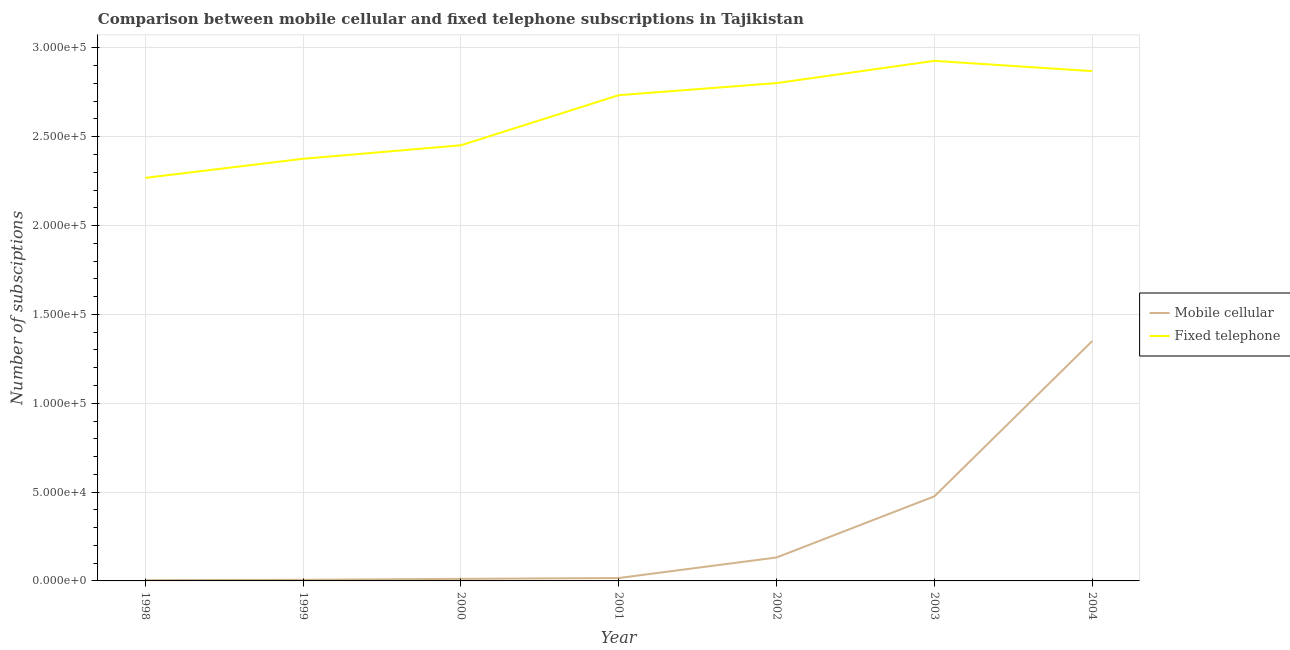Does the line corresponding to number of mobile cellular subscriptions intersect with the line corresponding to number of fixed telephone subscriptions?
Your response must be concise. No. Is the number of lines equal to the number of legend labels?
Make the answer very short. Yes. What is the number of mobile cellular subscriptions in 1998?
Your answer should be very brief. 420. Across all years, what is the maximum number of mobile cellular subscriptions?
Your response must be concise. 1.35e+05. Across all years, what is the minimum number of mobile cellular subscriptions?
Offer a very short reply. 420. In which year was the number of fixed telephone subscriptions maximum?
Your response must be concise. 2003. In which year was the number of fixed telephone subscriptions minimum?
Make the answer very short. 1998. What is the total number of fixed telephone subscriptions in the graph?
Provide a succinct answer. 1.84e+06. What is the difference between the number of fixed telephone subscriptions in 1999 and that in 2000?
Your response must be concise. -7592. What is the difference between the number of fixed telephone subscriptions in 1998 and the number of mobile cellular subscriptions in 2001?
Your answer should be compact. 2.25e+05. What is the average number of mobile cellular subscriptions per year?
Offer a very short reply. 2.85e+04. In the year 2004, what is the difference between the number of mobile cellular subscriptions and number of fixed telephone subscriptions?
Provide a short and direct response. -1.52e+05. What is the ratio of the number of mobile cellular subscriptions in 1999 to that in 2002?
Give a very brief answer. 0.05. Is the difference between the number of mobile cellular subscriptions in 2000 and 2001 greater than the difference between the number of fixed telephone subscriptions in 2000 and 2001?
Ensure brevity in your answer.  Yes. What is the difference between the highest and the second highest number of fixed telephone subscriptions?
Provide a short and direct response. 5790. What is the difference between the highest and the lowest number of fixed telephone subscriptions?
Your answer should be compact. 6.59e+04. Is the sum of the number of fixed telephone subscriptions in 1998 and 2004 greater than the maximum number of mobile cellular subscriptions across all years?
Make the answer very short. Yes. Is the number of mobile cellular subscriptions strictly greater than the number of fixed telephone subscriptions over the years?
Your answer should be compact. No. Is the number of mobile cellular subscriptions strictly less than the number of fixed telephone subscriptions over the years?
Offer a terse response. Yes. How many lines are there?
Provide a short and direct response. 2. How many years are there in the graph?
Make the answer very short. 7. What is the difference between two consecutive major ticks on the Y-axis?
Your response must be concise. 5.00e+04. Are the values on the major ticks of Y-axis written in scientific E-notation?
Your response must be concise. Yes. Does the graph contain grids?
Offer a terse response. Yes. Where does the legend appear in the graph?
Give a very brief answer. Center right. What is the title of the graph?
Make the answer very short. Comparison between mobile cellular and fixed telephone subscriptions in Tajikistan. Does "Age 65(male)" appear as one of the legend labels in the graph?
Provide a short and direct response. No. What is the label or title of the Y-axis?
Make the answer very short. Number of subsciptions. What is the Number of subsciptions in Mobile cellular in 1998?
Provide a succinct answer. 420. What is the Number of subsciptions in Fixed telephone in 1998?
Your answer should be very brief. 2.27e+05. What is the Number of subsciptions in Mobile cellular in 1999?
Your answer should be compact. 625. What is the Number of subsciptions in Fixed telephone in 1999?
Your answer should be very brief. 2.38e+05. What is the Number of subsciptions in Mobile cellular in 2000?
Make the answer very short. 1160. What is the Number of subsciptions of Fixed telephone in 2000?
Offer a very short reply. 2.45e+05. What is the Number of subsciptions in Mobile cellular in 2001?
Your answer should be compact. 1630. What is the Number of subsciptions of Fixed telephone in 2001?
Offer a very short reply. 2.73e+05. What is the Number of subsciptions in Mobile cellular in 2002?
Offer a very short reply. 1.32e+04. What is the Number of subsciptions of Fixed telephone in 2002?
Make the answer very short. 2.80e+05. What is the Number of subsciptions in Mobile cellular in 2003?
Your response must be concise. 4.76e+04. What is the Number of subsciptions in Fixed telephone in 2003?
Offer a very short reply. 2.93e+05. What is the Number of subsciptions in Mobile cellular in 2004?
Your answer should be very brief. 1.35e+05. What is the Number of subsciptions of Fixed telephone in 2004?
Offer a terse response. 2.87e+05. Across all years, what is the maximum Number of subsciptions of Mobile cellular?
Provide a succinct answer. 1.35e+05. Across all years, what is the maximum Number of subsciptions in Fixed telephone?
Your answer should be very brief. 2.93e+05. Across all years, what is the minimum Number of subsciptions in Mobile cellular?
Keep it short and to the point. 420. Across all years, what is the minimum Number of subsciptions of Fixed telephone?
Provide a succinct answer. 2.27e+05. What is the total Number of subsciptions in Mobile cellular in the graph?
Give a very brief answer. 2.00e+05. What is the total Number of subsciptions of Fixed telephone in the graph?
Keep it short and to the point. 1.84e+06. What is the difference between the Number of subsciptions in Mobile cellular in 1998 and that in 1999?
Offer a terse response. -205. What is the difference between the Number of subsciptions in Fixed telephone in 1998 and that in 1999?
Provide a short and direct response. -1.07e+04. What is the difference between the Number of subsciptions of Mobile cellular in 1998 and that in 2000?
Make the answer very short. -740. What is the difference between the Number of subsciptions in Fixed telephone in 1998 and that in 2000?
Offer a terse response. -1.83e+04. What is the difference between the Number of subsciptions in Mobile cellular in 1998 and that in 2001?
Offer a terse response. -1210. What is the difference between the Number of subsciptions of Fixed telephone in 1998 and that in 2001?
Your response must be concise. -4.65e+04. What is the difference between the Number of subsciptions of Mobile cellular in 1998 and that in 2002?
Provide a succinct answer. -1.28e+04. What is the difference between the Number of subsciptions in Fixed telephone in 1998 and that in 2002?
Give a very brief answer. -5.33e+04. What is the difference between the Number of subsciptions in Mobile cellular in 1998 and that in 2003?
Offer a very short reply. -4.72e+04. What is the difference between the Number of subsciptions of Fixed telephone in 1998 and that in 2003?
Your response must be concise. -6.59e+04. What is the difference between the Number of subsciptions in Mobile cellular in 1998 and that in 2004?
Your answer should be compact. -1.35e+05. What is the difference between the Number of subsciptions in Fixed telephone in 1998 and that in 2004?
Provide a succinct answer. -6.01e+04. What is the difference between the Number of subsciptions in Mobile cellular in 1999 and that in 2000?
Make the answer very short. -535. What is the difference between the Number of subsciptions in Fixed telephone in 1999 and that in 2000?
Your answer should be compact. -7592. What is the difference between the Number of subsciptions in Mobile cellular in 1999 and that in 2001?
Keep it short and to the point. -1005. What is the difference between the Number of subsciptions of Fixed telephone in 1999 and that in 2001?
Your response must be concise. -3.58e+04. What is the difference between the Number of subsciptions of Mobile cellular in 1999 and that in 2002?
Provide a short and direct response. -1.26e+04. What is the difference between the Number of subsciptions of Fixed telephone in 1999 and that in 2002?
Give a very brief answer. -4.26e+04. What is the difference between the Number of subsciptions in Mobile cellular in 1999 and that in 2003?
Offer a terse response. -4.70e+04. What is the difference between the Number of subsciptions of Fixed telephone in 1999 and that in 2003?
Provide a short and direct response. -5.51e+04. What is the difference between the Number of subsciptions in Mobile cellular in 1999 and that in 2004?
Your response must be concise. -1.34e+05. What is the difference between the Number of subsciptions in Fixed telephone in 1999 and that in 2004?
Provide a succinct answer. -4.93e+04. What is the difference between the Number of subsciptions in Mobile cellular in 2000 and that in 2001?
Provide a short and direct response. -470. What is the difference between the Number of subsciptions of Fixed telephone in 2000 and that in 2001?
Your answer should be very brief. -2.82e+04. What is the difference between the Number of subsciptions of Mobile cellular in 2000 and that in 2002?
Make the answer very short. -1.20e+04. What is the difference between the Number of subsciptions in Fixed telephone in 2000 and that in 2002?
Your answer should be very brief. -3.50e+04. What is the difference between the Number of subsciptions of Mobile cellular in 2000 and that in 2003?
Offer a terse response. -4.65e+04. What is the difference between the Number of subsciptions of Fixed telephone in 2000 and that in 2003?
Your answer should be very brief. -4.75e+04. What is the difference between the Number of subsciptions in Mobile cellular in 2000 and that in 2004?
Provide a succinct answer. -1.34e+05. What is the difference between the Number of subsciptions of Fixed telephone in 2000 and that in 2004?
Your answer should be very brief. -4.17e+04. What is the difference between the Number of subsciptions in Mobile cellular in 2001 and that in 2002?
Make the answer very short. -1.16e+04. What is the difference between the Number of subsciptions in Fixed telephone in 2001 and that in 2002?
Give a very brief answer. -6800. What is the difference between the Number of subsciptions of Mobile cellular in 2001 and that in 2003?
Provide a succinct answer. -4.60e+04. What is the difference between the Number of subsciptions in Fixed telephone in 2001 and that in 2003?
Make the answer very short. -1.93e+04. What is the difference between the Number of subsciptions of Mobile cellular in 2001 and that in 2004?
Make the answer very short. -1.33e+05. What is the difference between the Number of subsciptions in Fixed telephone in 2001 and that in 2004?
Your answer should be very brief. -1.35e+04. What is the difference between the Number of subsciptions in Mobile cellular in 2002 and that in 2003?
Make the answer very short. -3.44e+04. What is the difference between the Number of subsciptions in Fixed telephone in 2002 and that in 2003?
Ensure brevity in your answer.  -1.25e+04. What is the difference between the Number of subsciptions in Mobile cellular in 2002 and that in 2004?
Your response must be concise. -1.22e+05. What is the difference between the Number of subsciptions of Fixed telephone in 2002 and that in 2004?
Make the answer very short. -6740. What is the difference between the Number of subsciptions in Mobile cellular in 2003 and that in 2004?
Ensure brevity in your answer.  -8.74e+04. What is the difference between the Number of subsciptions in Fixed telephone in 2003 and that in 2004?
Ensure brevity in your answer.  5790. What is the difference between the Number of subsciptions of Mobile cellular in 1998 and the Number of subsciptions of Fixed telephone in 1999?
Make the answer very short. -2.37e+05. What is the difference between the Number of subsciptions of Mobile cellular in 1998 and the Number of subsciptions of Fixed telephone in 2000?
Give a very brief answer. -2.45e+05. What is the difference between the Number of subsciptions of Mobile cellular in 1998 and the Number of subsciptions of Fixed telephone in 2001?
Offer a terse response. -2.73e+05. What is the difference between the Number of subsciptions of Mobile cellular in 1998 and the Number of subsciptions of Fixed telephone in 2002?
Your answer should be compact. -2.80e+05. What is the difference between the Number of subsciptions of Mobile cellular in 1998 and the Number of subsciptions of Fixed telephone in 2003?
Keep it short and to the point. -2.92e+05. What is the difference between the Number of subsciptions in Mobile cellular in 1998 and the Number of subsciptions in Fixed telephone in 2004?
Give a very brief answer. -2.87e+05. What is the difference between the Number of subsciptions of Mobile cellular in 1999 and the Number of subsciptions of Fixed telephone in 2000?
Your answer should be very brief. -2.45e+05. What is the difference between the Number of subsciptions in Mobile cellular in 1999 and the Number of subsciptions in Fixed telephone in 2001?
Ensure brevity in your answer.  -2.73e+05. What is the difference between the Number of subsciptions of Mobile cellular in 1999 and the Number of subsciptions of Fixed telephone in 2002?
Your answer should be compact. -2.80e+05. What is the difference between the Number of subsciptions in Mobile cellular in 1999 and the Number of subsciptions in Fixed telephone in 2003?
Make the answer very short. -2.92e+05. What is the difference between the Number of subsciptions of Mobile cellular in 1999 and the Number of subsciptions of Fixed telephone in 2004?
Your answer should be compact. -2.86e+05. What is the difference between the Number of subsciptions in Mobile cellular in 2000 and the Number of subsciptions in Fixed telephone in 2001?
Provide a succinct answer. -2.72e+05. What is the difference between the Number of subsciptions of Mobile cellular in 2000 and the Number of subsciptions of Fixed telephone in 2002?
Your answer should be compact. -2.79e+05. What is the difference between the Number of subsciptions of Mobile cellular in 2000 and the Number of subsciptions of Fixed telephone in 2003?
Give a very brief answer. -2.92e+05. What is the difference between the Number of subsciptions of Mobile cellular in 2000 and the Number of subsciptions of Fixed telephone in 2004?
Provide a short and direct response. -2.86e+05. What is the difference between the Number of subsciptions in Mobile cellular in 2001 and the Number of subsciptions in Fixed telephone in 2002?
Give a very brief answer. -2.79e+05. What is the difference between the Number of subsciptions of Mobile cellular in 2001 and the Number of subsciptions of Fixed telephone in 2003?
Provide a succinct answer. -2.91e+05. What is the difference between the Number of subsciptions in Mobile cellular in 2001 and the Number of subsciptions in Fixed telephone in 2004?
Provide a short and direct response. -2.85e+05. What is the difference between the Number of subsciptions in Mobile cellular in 2002 and the Number of subsciptions in Fixed telephone in 2003?
Provide a short and direct response. -2.80e+05. What is the difference between the Number of subsciptions in Mobile cellular in 2002 and the Number of subsciptions in Fixed telephone in 2004?
Offer a very short reply. -2.74e+05. What is the difference between the Number of subsciptions in Mobile cellular in 2003 and the Number of subsciptions in Fixed telephone in 2004?
Provide a short and direct response. -2.39e+05. What is the average Number of subsciptions in Mobile cellular per year?
Give a very brief answer. 2.85e+04. What is the average Number of subsciptions of Fixed telephone per year?
Offer a terse response. 2.63e+05. In the year 1998, what is the difference between the Number of subsciptions of Mobile cellular and Number of subsciptions of Fixed telephone?
Provide a short and direct response. -2.26e+05. In the year 1999, what is the difference between the Number of subsciptions of Mobile cellular and Number of subsciptions of Fixed telephone?
Provide a short and direct response. -2.37e+05. In the year 2000, what is the difference between the Number of subsciptions of Mobile cellular and Number of subsciptions of Fixed telephone?
Offer a terse response. -2.44e+05. In the year 2001, what is the difference between the Number of subsciptions of Mobile cellular and Number of subsciptions of Fixed telephone?
Make the answer very short. -2.72e+05. In the year 2002, what is the difference between the Number of subsciptions in Mobile cellular and Number of subsciptions in Fixed telephone?
Provide a short and direct response. -2.67e+05. In the year 2003, what is the difference between the Number of subsciptions of Mobile cellular and Number of subsciptions of Fixed telephone?
Offer a terse response. -2.45e+05. In the year 2004, what is the difference between the Number of subsciptions in Mobile cellular and Number of subsciptions in Fixed telephone?
Offer a very short reply. -1.52e+05. What is the ratio of the Number of subsciptions in Mobile cellular in 1998 to that in 1999?
Offer a terse response. 0.67. What is the ratio of the Number of subsciptions in Fixed telephone in 1998 to that in 1999?
Your answer should be very brief. 0.95. What is the ratio of the Number of subsciptions in Mobile cellular in 1998 to that in 2000?
Keep it short and to the point. 0.36. What is the ratio of the Number of subsciptions in Fixed telephone in 1998 to that in 2000?
Offer a terse response. 0.93. What is the ratio of the Number of subsciptions in Mobile cellular in 1998 to that in 2001?
Your answer should be compact. 0.26. What is the ratio of the Number of subsciptions in Fixed telephone in 1998 to that in 2001?
Keep it short and to the point. 0.83. What is the ratio of the Number of subsciptions of Mobile cellular in 1998 to that in 2002?
Offer a terse response. 0.03. What is the ratio of the Number of subsciptions of Fixed telephone in 1998 to that in 2002?
Give a very brief answer. 0.81. What is the ratio of the Number of subsciptions in Mobile cellular in 1998 to that in 2003?
Ensure brevity in your answer.  0.01. What is the ratio of the Number of subsciptions of Fixed telephone in 1998 to that in 2003?
Ensure brevity in your answer.  0.77. What is the ratio of the Number of subsciptions in Mobile cellular in 1998 to that in 2004?
Give a very brief answer. 0. What is the ratio of the Number of subsciptions of Fixed telephone in 1998 to that in 2004?
Your answer should be compact. 0.79. What is the ratio of the Number of subsciptions in Mobile cellular in 1999 to that in 2000?
Your answer should be compact. 0.54. What is the ratio of the Number of subsciptions in Mobile cellular in 1999 to that in 2001?
Offer a terse response. 0.38. What is the ratio of the Number of subsciptions of Fixed telephone in 1999 to that in 2001?
Give a very brief answer. 0.87. What is the ratio of the Number of subsciptions of Mobile cellular in 1999 to that in 2002?
Provide a short and direct response. 0.05. What is the ratio of the Number of subsciptions of Fixed telephone in 1999 to that in 2002?
Give a very brief answer. 0.85. What is the ratio of the Number of subsciptions of Mobile cellular in 1999 to that in 2003?
Provide a short and direct response. 0.01. What is the ratio of the Number of subsciptions of Fixed telephone in 1999 to that in 2003?
Provide a short and direct response. 0.81. What is the ratio of the Number of subsciptions in Mobile cellular in 1999 to that in 2004?
Your response must be concise. 0. What is the ratio of the Number of subsciptions of Fixed telephone in 1999 to that in 2004?
Make the answer very short. 0.83. What is the ratio of the Number of subsciptions of Mobile cellular in 2000 to that in 2001?
Keep it short and to the point. 0.71. What is the ratio of the Number of subsciptions in Fixed telephone in 2000 to that in 2001?
Your answer should be compact. 0.9. What is the ratio of the Number of subsciptions in Mobile cellular in 2000 to that in 2002?
Ensure brevity in your answer.  0.09. What is the ratio of the Number of subsciptions in Fixed telephone in 2000 to that in 2002?
Your answer should be compact. 0.88. What is the ratio of the Number of subsciptions of Mobile cellular in 2000 to that in 2003?
Offer a terse response. 0.02. What is the ratio of the Number of subsciptions of Fixed telephone in 2000 to that in 2003?
Your answer should be compact. 0.84. What is the ratio of the Number of subsciptions of Mobile cellular in 2000 to that in 2004?
Your response must be concise. 0.01. What is the ratio of the Number of subsciptions in Fixed telephone in 2000 to that in 2004?
Give a very brief answer. 0.85. What is the ratio of the Number of subsciptions in Mobile cellular in 2001 to that in 2002?
Give a very brief answer. 0.12. What is the ratio of the Number of subsciptions in Fixed telephone in 2001 to that in 2002?
Offer a terse response. 0.98. What is the ratio of the Number of subsciptions in Mobile cellular in 2001 to that in 2003?
Provide a succinct answer. 0.03. What is the ratio of the Number of subsciptions of Fixed telephone in 2001 to that in 2003?
Your answer should be very brief. 0.93. What is the ratio of the Number of subsciptions of Mobile cellular in 2001 to that in 2004?
Make the answer very short. 0.01. What is the ratio of the Number of subsciptions of Fixed telephone in 2001 to that in 2004?
Your answer should be very brief. 0.95. What is the ratio of the Number of subsciptions of Mobile cellular in 2002 to that in 2003?
Provide a succinct answer. 0.28. What is the ratio of the Number of subsciptions in Fixed telephone in 2002 to that in 2003?
Offer a terse response. 0.96. What is the ratio of the Number of subsciptions of Mobile cellular in 2002 to that in 2004?
Keep it short and to the point. 0.1. What is the ratio of the Number of subsciptions of Fixed telephone in 2002 to that in 2004?
Your response must be concise. 0.98. What is the ratio of the Number of subsciptions of Mobile cellular in 2003 to that in 2004?
Ensure brevity in your answer.  0.35. What is the ratio of the Number of subsciptions in Fixed telephone in 2003 to that in 2004?
Make the answer very short. 1.02. What is the difference between the highest and the second highest Number of subsciptions of Mobile cellular?
Offer a very short reply. 8.74e+04. What is the difference between the highest and the second highest Number of subsciptions of Fixed telephone?
Make the answer very short. 5790. What is the difference between the highest and the lowest Number of subsciptions in Mobile cellular?
Keep it short and to the point. 1.35e+05. What is the difference between the highest and the lowest Number of subsciptions in Fixed telephone?
Make the answer very short. 6.59e+04. 